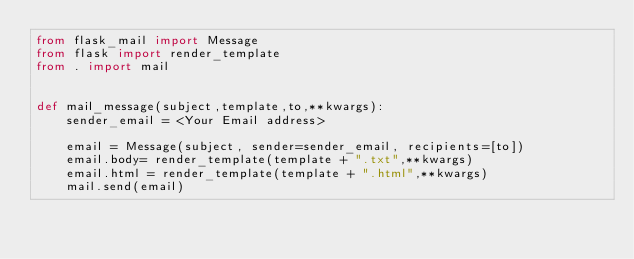Convert code to text. <code><loc_0><loc_0><loc_500><loc_500><_Python_>from flask_mail import Message
from flask import render_template
from . import mail


def mail_message(subject,template,to,**kwargs):
    sender_email = <Your Email address>

    email = Message(subject, sender=sender_email, recipients=[to])
    email.body= render_template(template + ".txt",**kwargs)
    email.html = render_template(template + ".html",**kwargs)
    mail.send(email)
</code> 